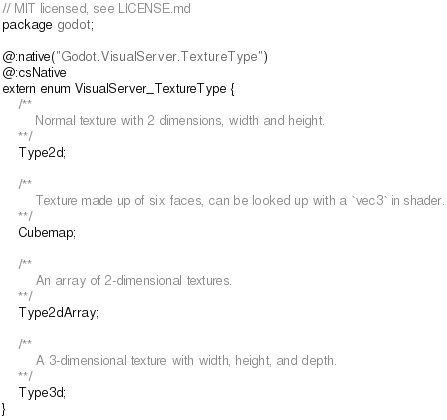Convert code to text. <code><loc_0><loc_0><loc_500><loc_500><_Haxe_>// MIT licensed, see LICENSE.md
package godot;

@:native("Godot.VisualServer.TextureType")
@:csNative
extern enum VisualServer_TextureType {
	/**		
		Normal texture with 2 dimensions, width and height.
	**/
	Type2d;

	/**		
		Texture made up of six faces, can be looked up with a `vec3` in shader.
	**/
	Cubemap;

	/**		
		An array of 2-dimensional textures.
	**/
	Type2dArray;

	/**		
		A 3-dimensional texture with width, height, and depth.
	**/
	Type3d;
}
</code> 